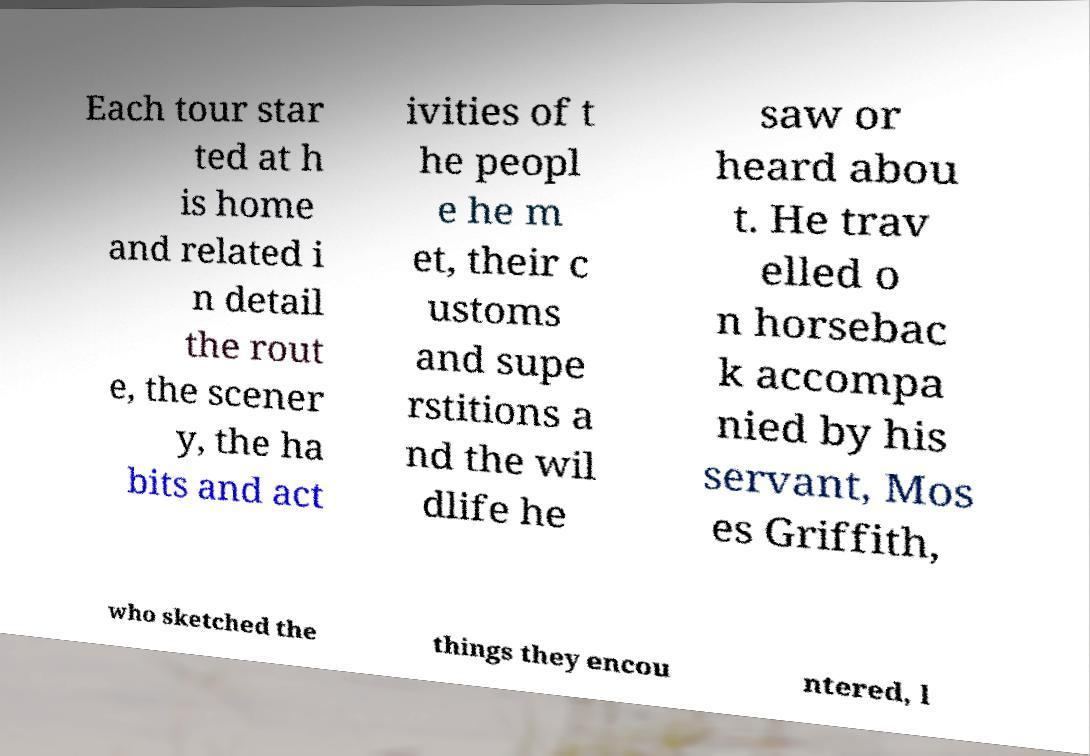Can you read and provide the text displayed in the image?This photo seems to have some interesting text. Can you extract and type it out for me? Each tour star ted at h is home and related i n detail the rout e, the scener y, the ha bits and act ivities of t he peopl e he m et, their c ustoms and supe rstitions a nd the wil dlife he saw or heard abou t. He trav elled o n horsebac k accompa nied by his servant, Mos es Griffith, who sketched the things they encou ntered, l 